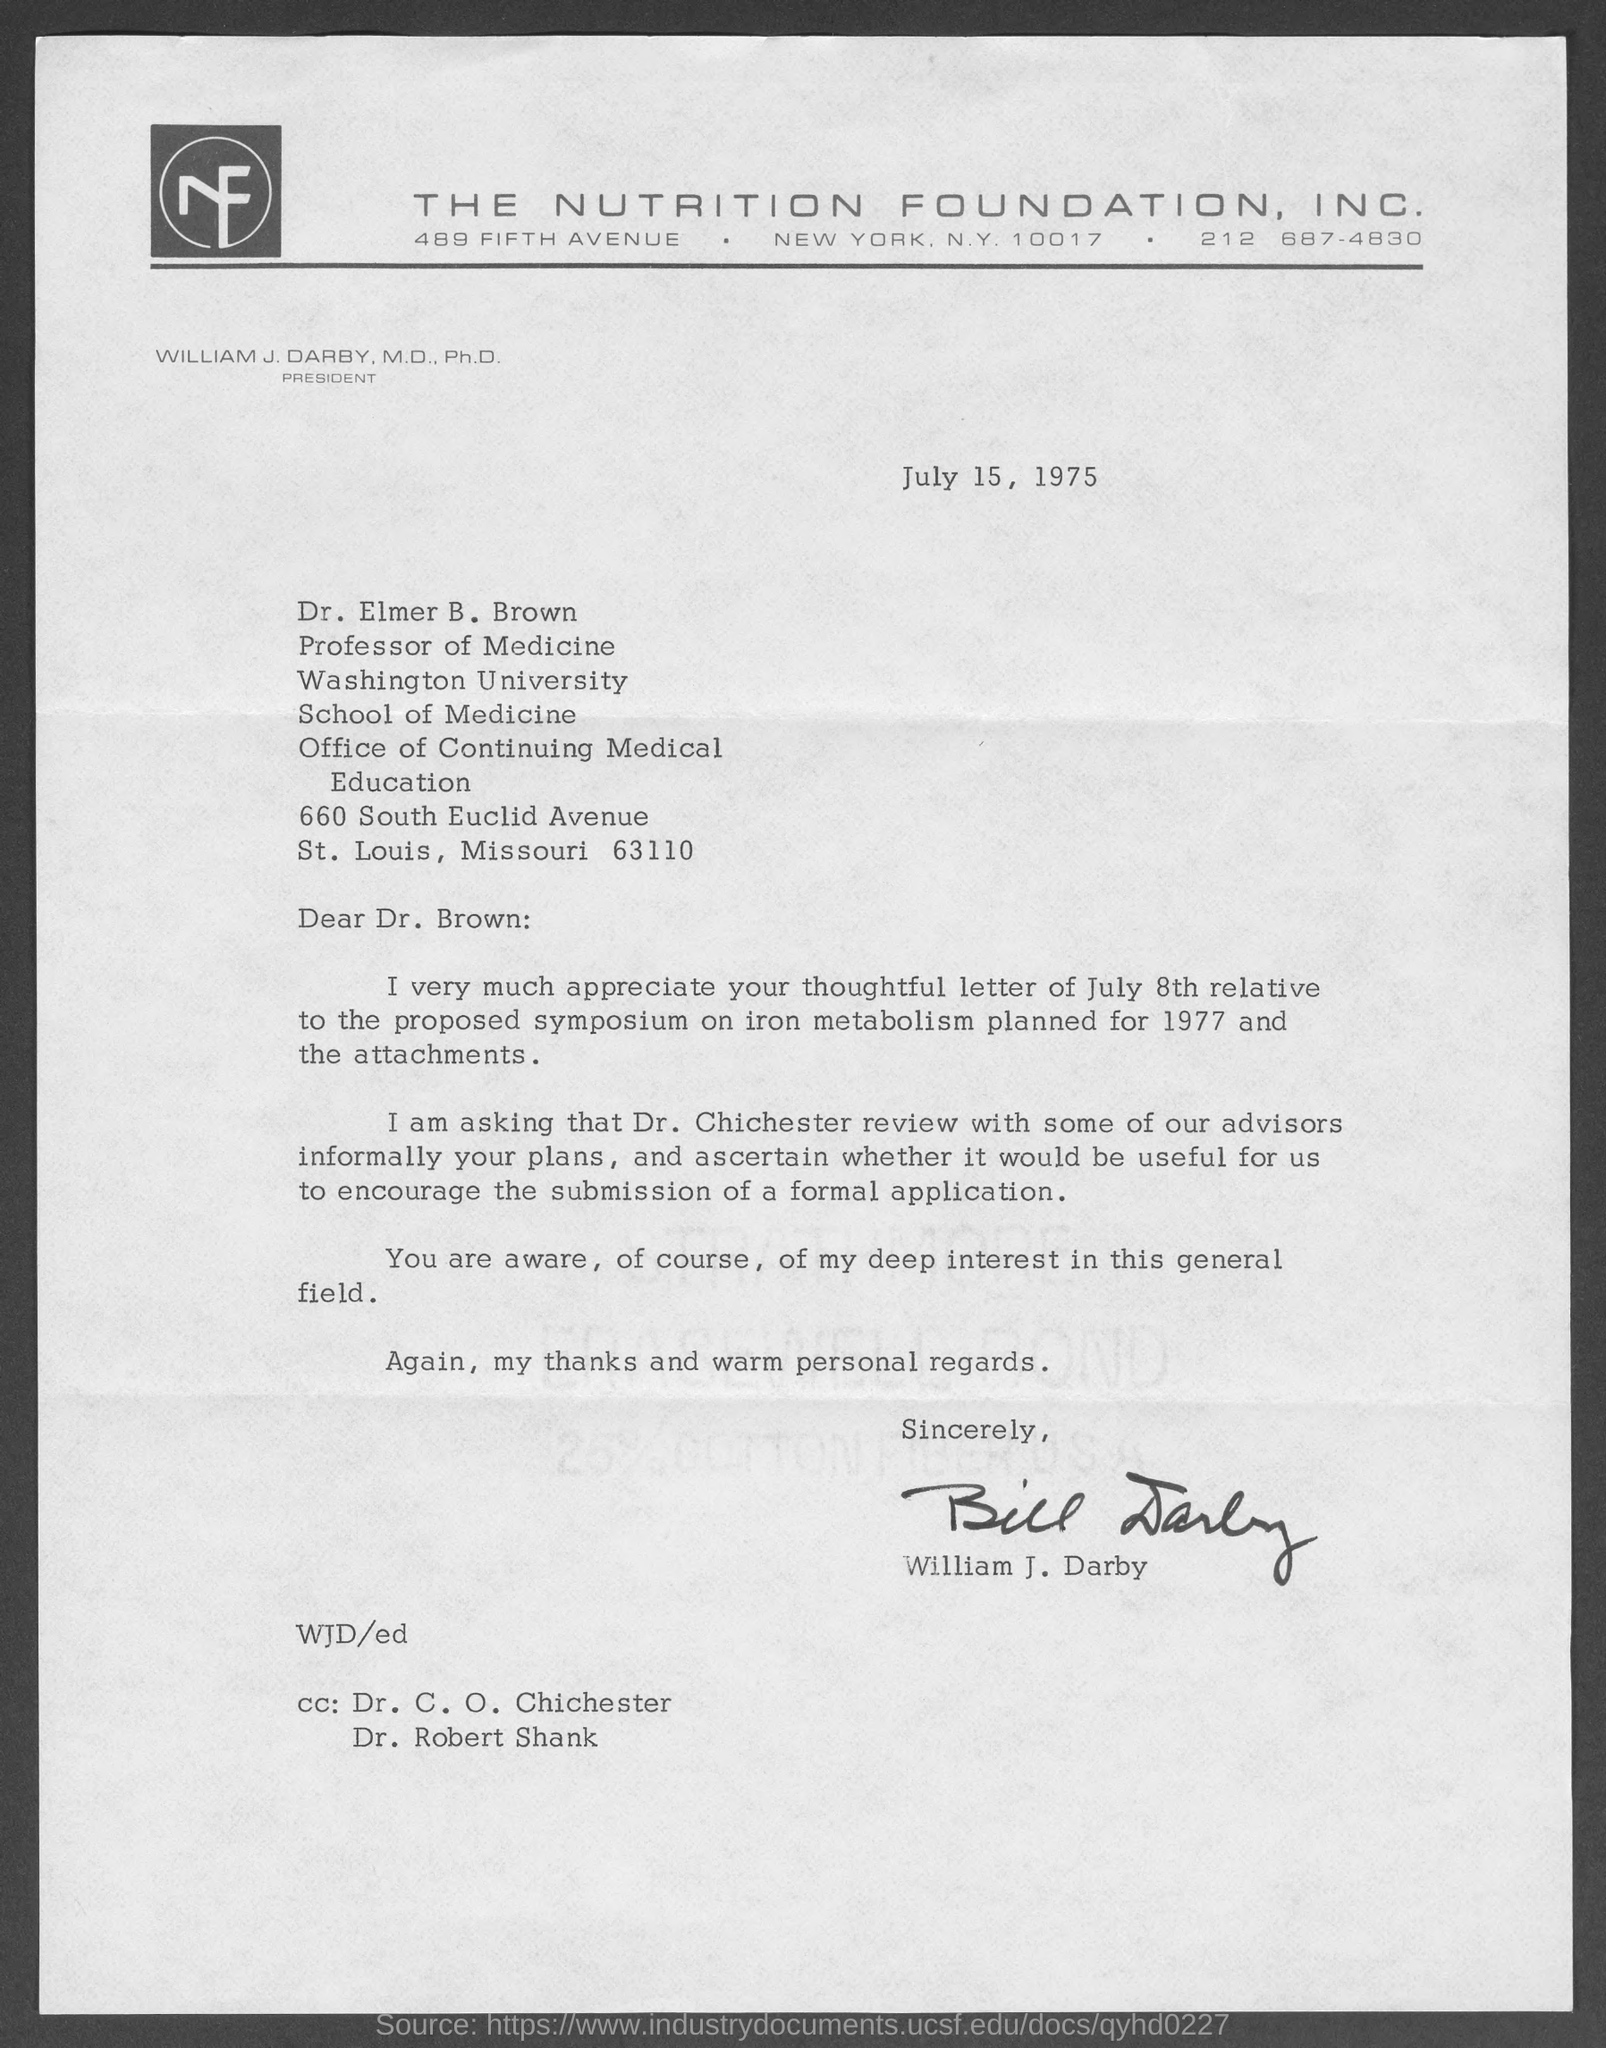Which foundation is mentioned at the top of the page?
Give a very brief answer. THE NUTRITION FOUNDATION, INC. When is the document dated?
Offer a very short reply. July 15, 1975. To whom is the letter addressed?
Give a very brief answer. Dr. Elmer B. Brown. What is the proposed symposium on?
Provide a succinct answer. Iron metabolism. Who will review with some of the advisors informally about Dr. Brown's plans?
Provide a succinct answer. Dr. Chichester. Who has signed the letter?
Offer a very short reply. William J. Darby. 